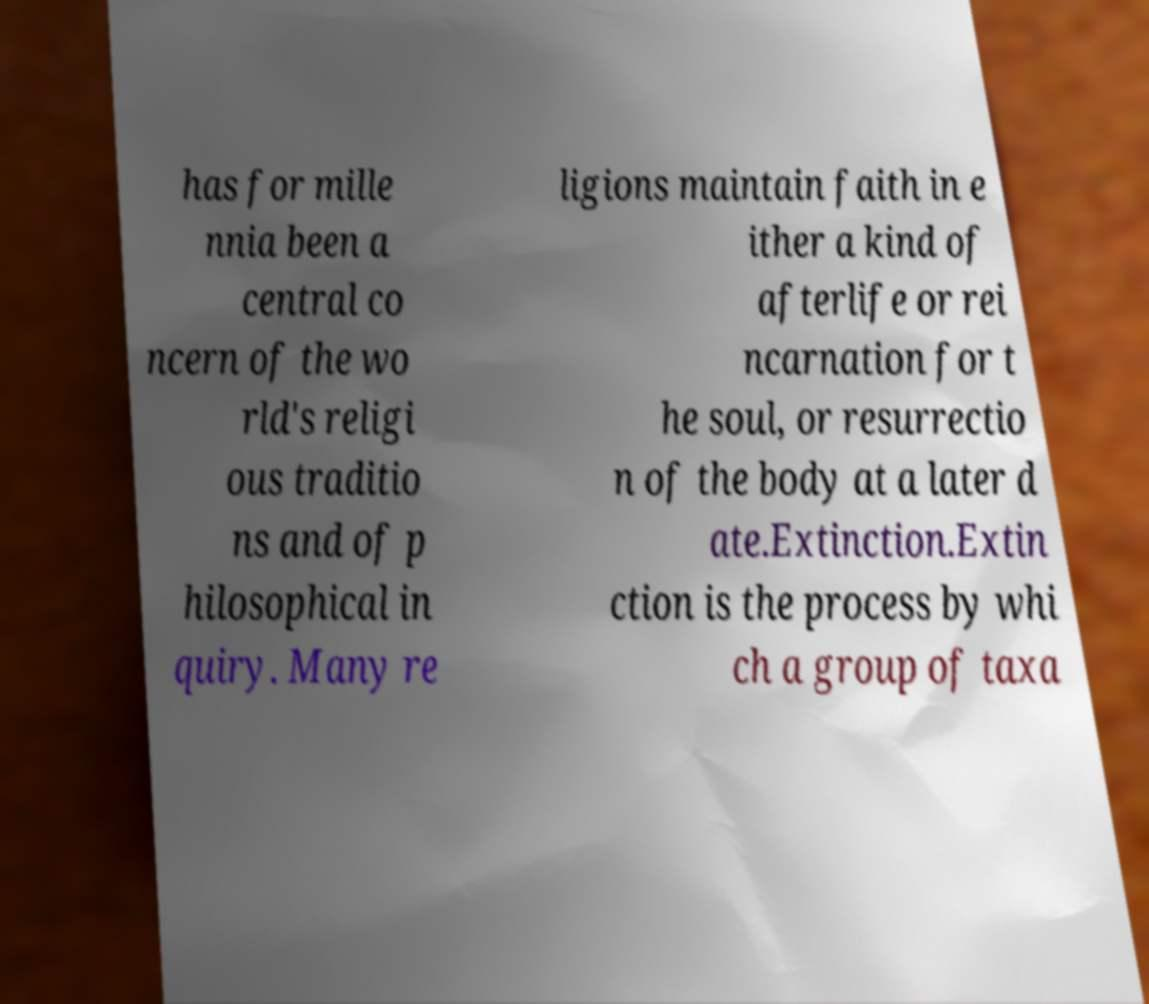Could you extract and type out the text from this image? has for mille nnia been a central co ncern of the wo rld's religi ous traditio ns and of p hilosophical in quiry. Many re ligions maintain faith in e ither a kind of afterlife or rei ncarnation for t he soul, or resurrectio n of the body at a later d ate.Extinction.Extin ction is the process by whi ch a group of taxa 